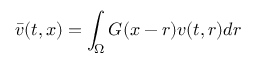<formula> <loc_0><loc_0><loc_500><loc_500>\bar { v } ( t , x ) = \int _ { \Omega } G ( x - r ) v ( t , r ) d r</formula> 